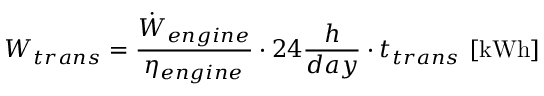<formula> <loc_0><loc_0><loc_500><loc_500>W _ { t r a n s } = \frac { \dot { W } _ { e n g i n e } } { \eta _ { e n g i n e } } \cdot 2 4 \frac { h } { d a y } \cdot { t } _ { t r a n s } \ [ k W h ]</formula> 